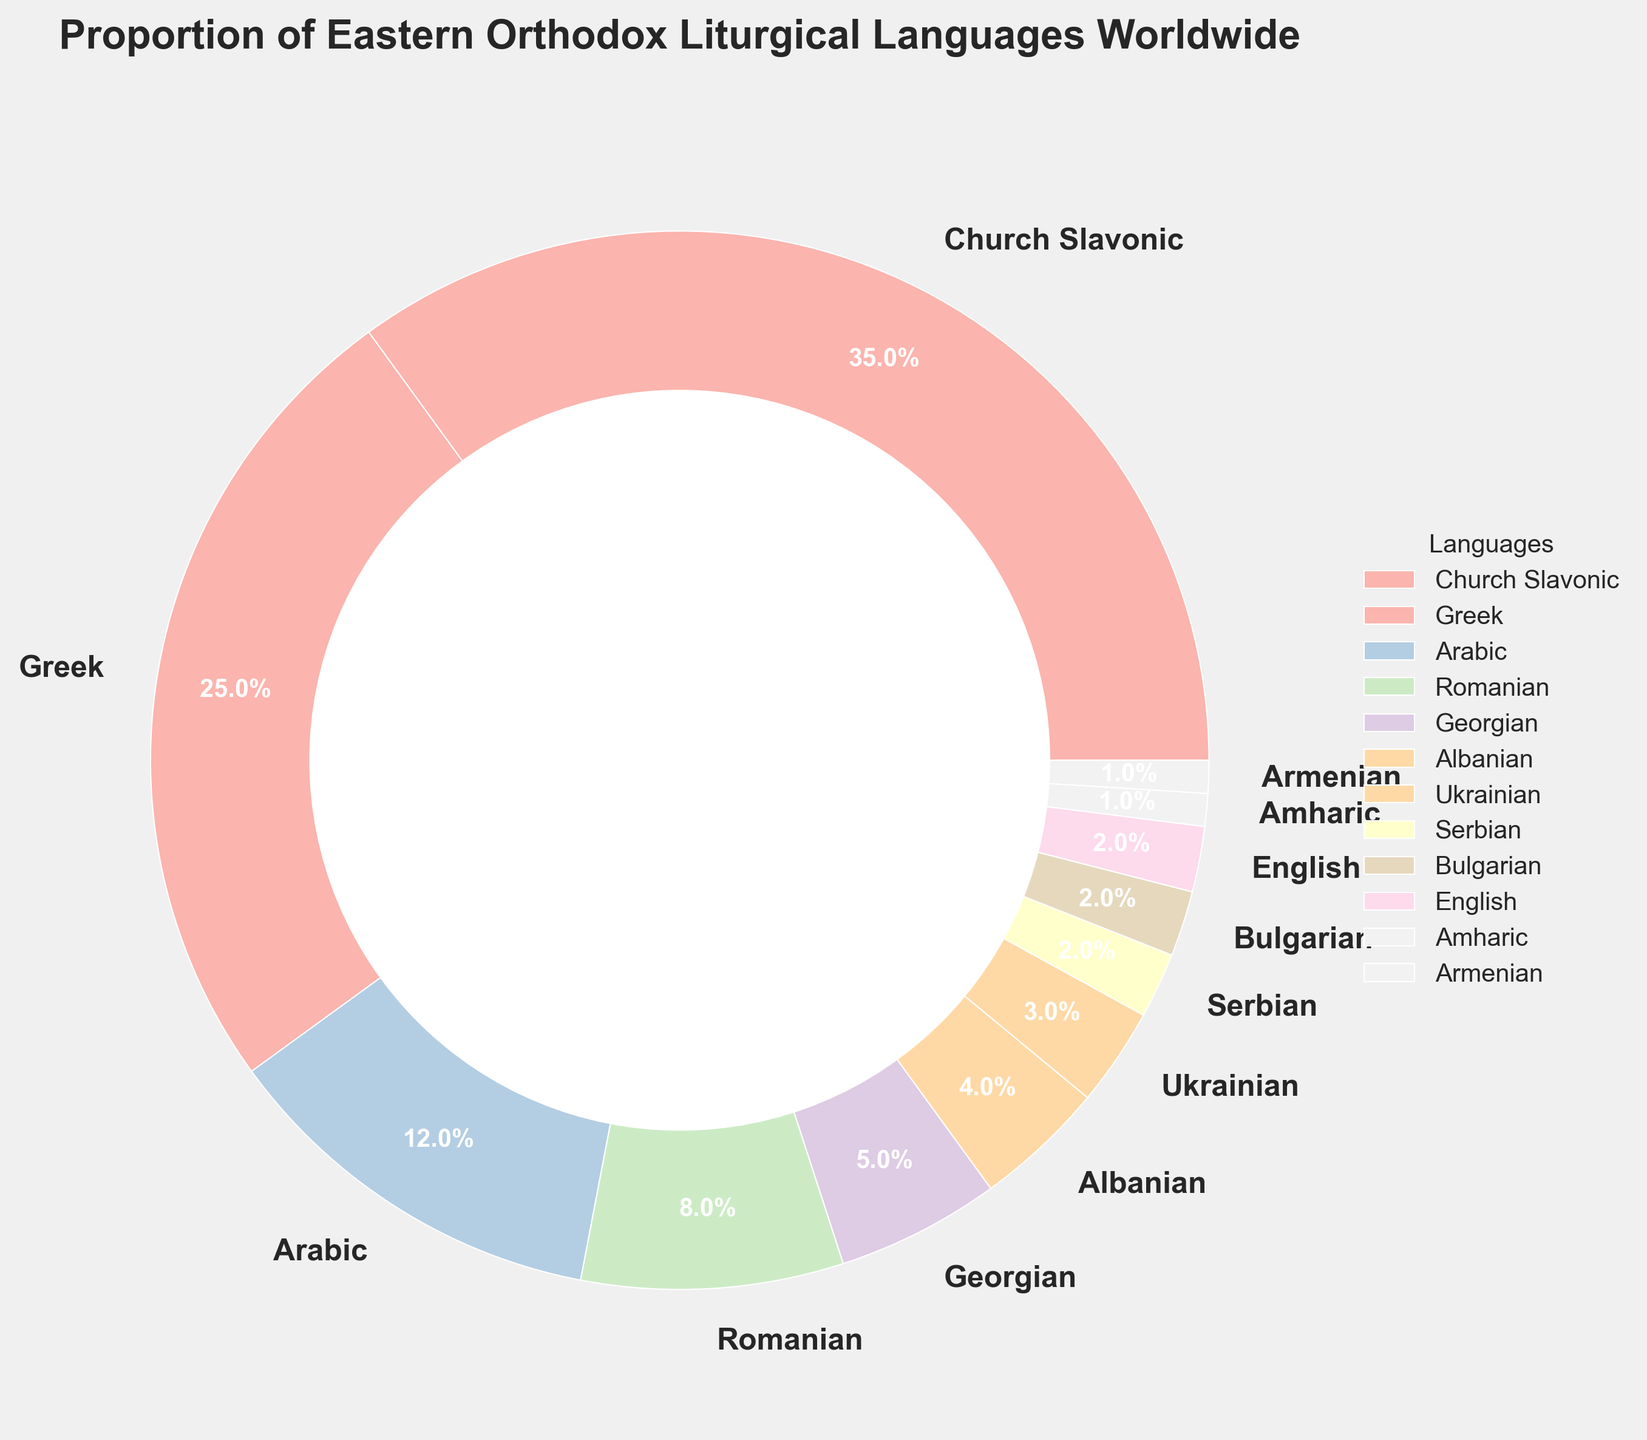What is the most widely used liturgical language in the Eastern Orthodox Church based on the pie chart? By observing the pie chart, it is evident that Church Slavonic occupies the largest portion. The label on this section indicates that it contributes 35% of the total.
Answer: Church Slavonic Which two languages together make up exactly half of the liturgical use? Church Slavonic and Greek together represent the largest portions. By adding their percentages: 35% (Church Slavonic) + 25% (Greek) = 60%, which is more than half. The next largest languages are Arabic and Romanian, where 35% + 25% = 60% > 50%. Therefore, the two largest categories are already over 50%.
Answer: Church Slavonic and Greek How many languages have a smaller percentage than Albanian? Albanian has a percentage of 4%. Languages with smaller percentages are Ukrainian (3%), Serbian (2%), Bulgarian (2%), English (2%), Amharic (1%), and Armenian (1%). Counting these, there are six languages.
Answer: Six languages Which language segment is visually the closest in size to Romanian? Romanian is represented by 8% of the pie chart. Georgian follows closely with 5%, and Albanian has 4%. Georgian is visually closer because it is the next largest segment following Romanian.
Answer: Georgian What is the combined percentage of Georgian, Albanian, and Ukrainian liturgical uses? Adding the percentages of these languages, Georgian (5%), Albanian (4%), and Ukrainian (3%): 5% + 4% + 3% = 12%.
Answer: 12% How many languages use less than 5% of the liturgical percentage? The languages with less than 5% are Albanian (4%), Ukrainian (3%), Serbian (2%), Bulgarian (2%), English (2%), Amharic (1%), and Armenian (1%). Counting these, there are seven languages.
Answer: Seven languages Is the percentage of Arabic liturgical use greater than the combined use of Serbian, Bulgarian, and English? Arabic has 12%. Combining Serbian (2%), Bulgarian (2%), and English (2%): 2% + 2% + 2% = 6%, which is less than 12%.
Answer: Yes Which language has the least prominence in the Eastern Orthodox liturgical practices based on the pie chart? By observing the pie chart, both Amharic and Armenian each make up 1% of the total, indicating they are the least prominent.
Answer: Amharic and Armenian 